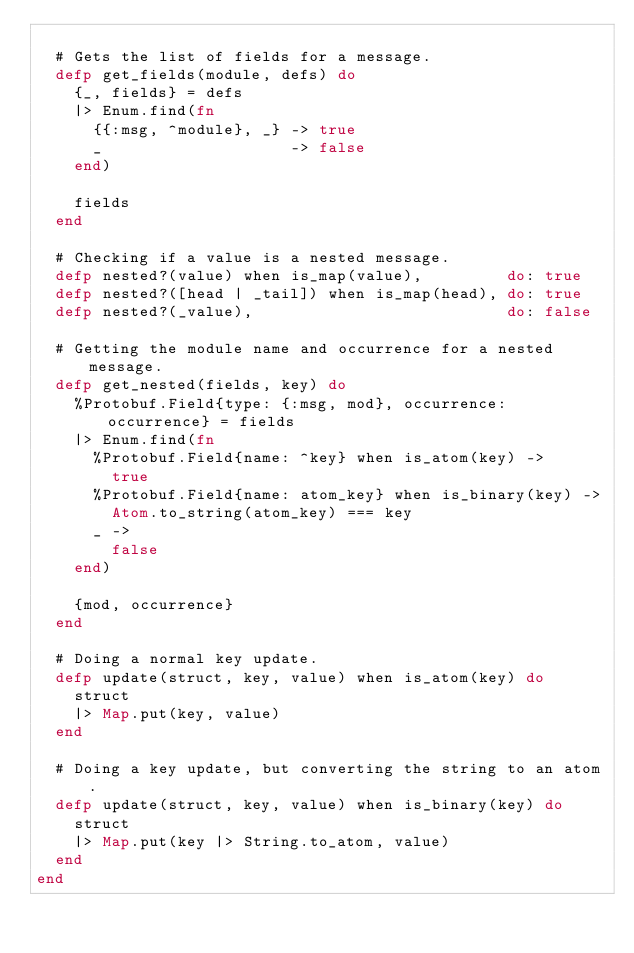<code> <loc_0><loc_0><loc_500><loc_500><_Elixir_>
  # Gets the list of fields for a message.
  defp get_fields(module, defs) do
    {_, fields} = defs
    |> Enum.find(fn
      {{:msg, ^module}, _} -> true
      _                    -> false
    end)

    fields
  end

  # Checking if a value is a nested message.
  defp nested?(value) when is_map(value),         do: true
  defp nested?([head | _tail]) when is_map(head), do: true
  defp nested?(_value),                           do: false

  # Getting the module name and occurrence for a nested message.
  defp get_nested(fields, key) do
    %Protobuf.Field{type: {:msg, mod}, occurrence: occurrence} = fields
    |> Enum.find(fn
      %Protobuf.Field{name: ^key} when is_atom(key) ->
        true
      %Protobuf.Field{name: atom_key} when is_binary(key) ->
        Atom.to_string(atom_key) === key
      _ ->
        false
    end)

    {mod, occurrence}
  end

  # Doing a normal key update.
  defp update(struct, key, value) when is_atom(key) do
    struct
    |> Map.put(key, value)
  end

  # Doing a key update, but converting the string to an atom.
  defp update(struct, key, value) when is_binary(key) do
    struct
    |> Map.put(key |> String.to_atom, value)
  end
end
</code> 